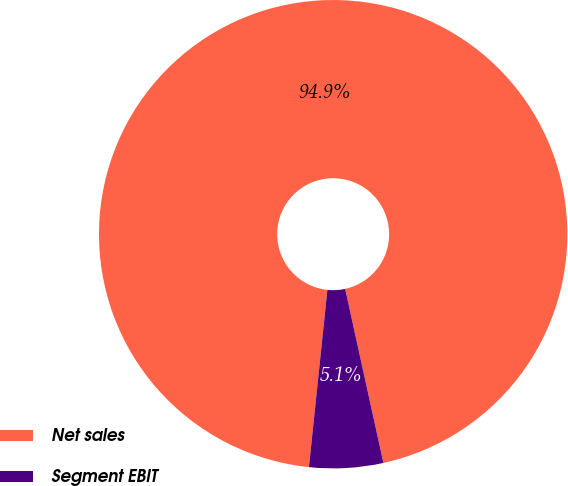<chart> <loc_0><loc_0><loc_500><loc_500><pie_chart><fcel>Net sales<fcel>Segment EBIT<nl><fcel>94.91%<fcel>5.09%<nl></chart> 